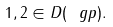<formula> <loc_0><loc_0><loc_500><loc_500>1 , 2 \in D ( \ g p ) .</formula> 